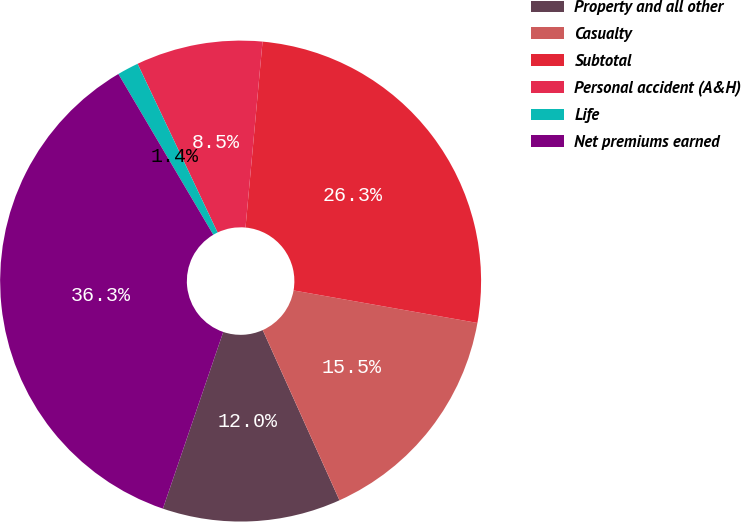Convert chart. <chart><loc_0><loc_0><loc_500><loc_500><pie_chart><fcel>Property and all other<fcel>Casualty<fcel>Subtotal<fcel>Personal accident (A&H)<fcel>Life<fcel>Net premiums earned<nl><fcel>11.98%<fcel>15.47%<fcel>26.33%<fcel>8.5%<fcel>1.44%<fcel>36.27%<nl></chart> 